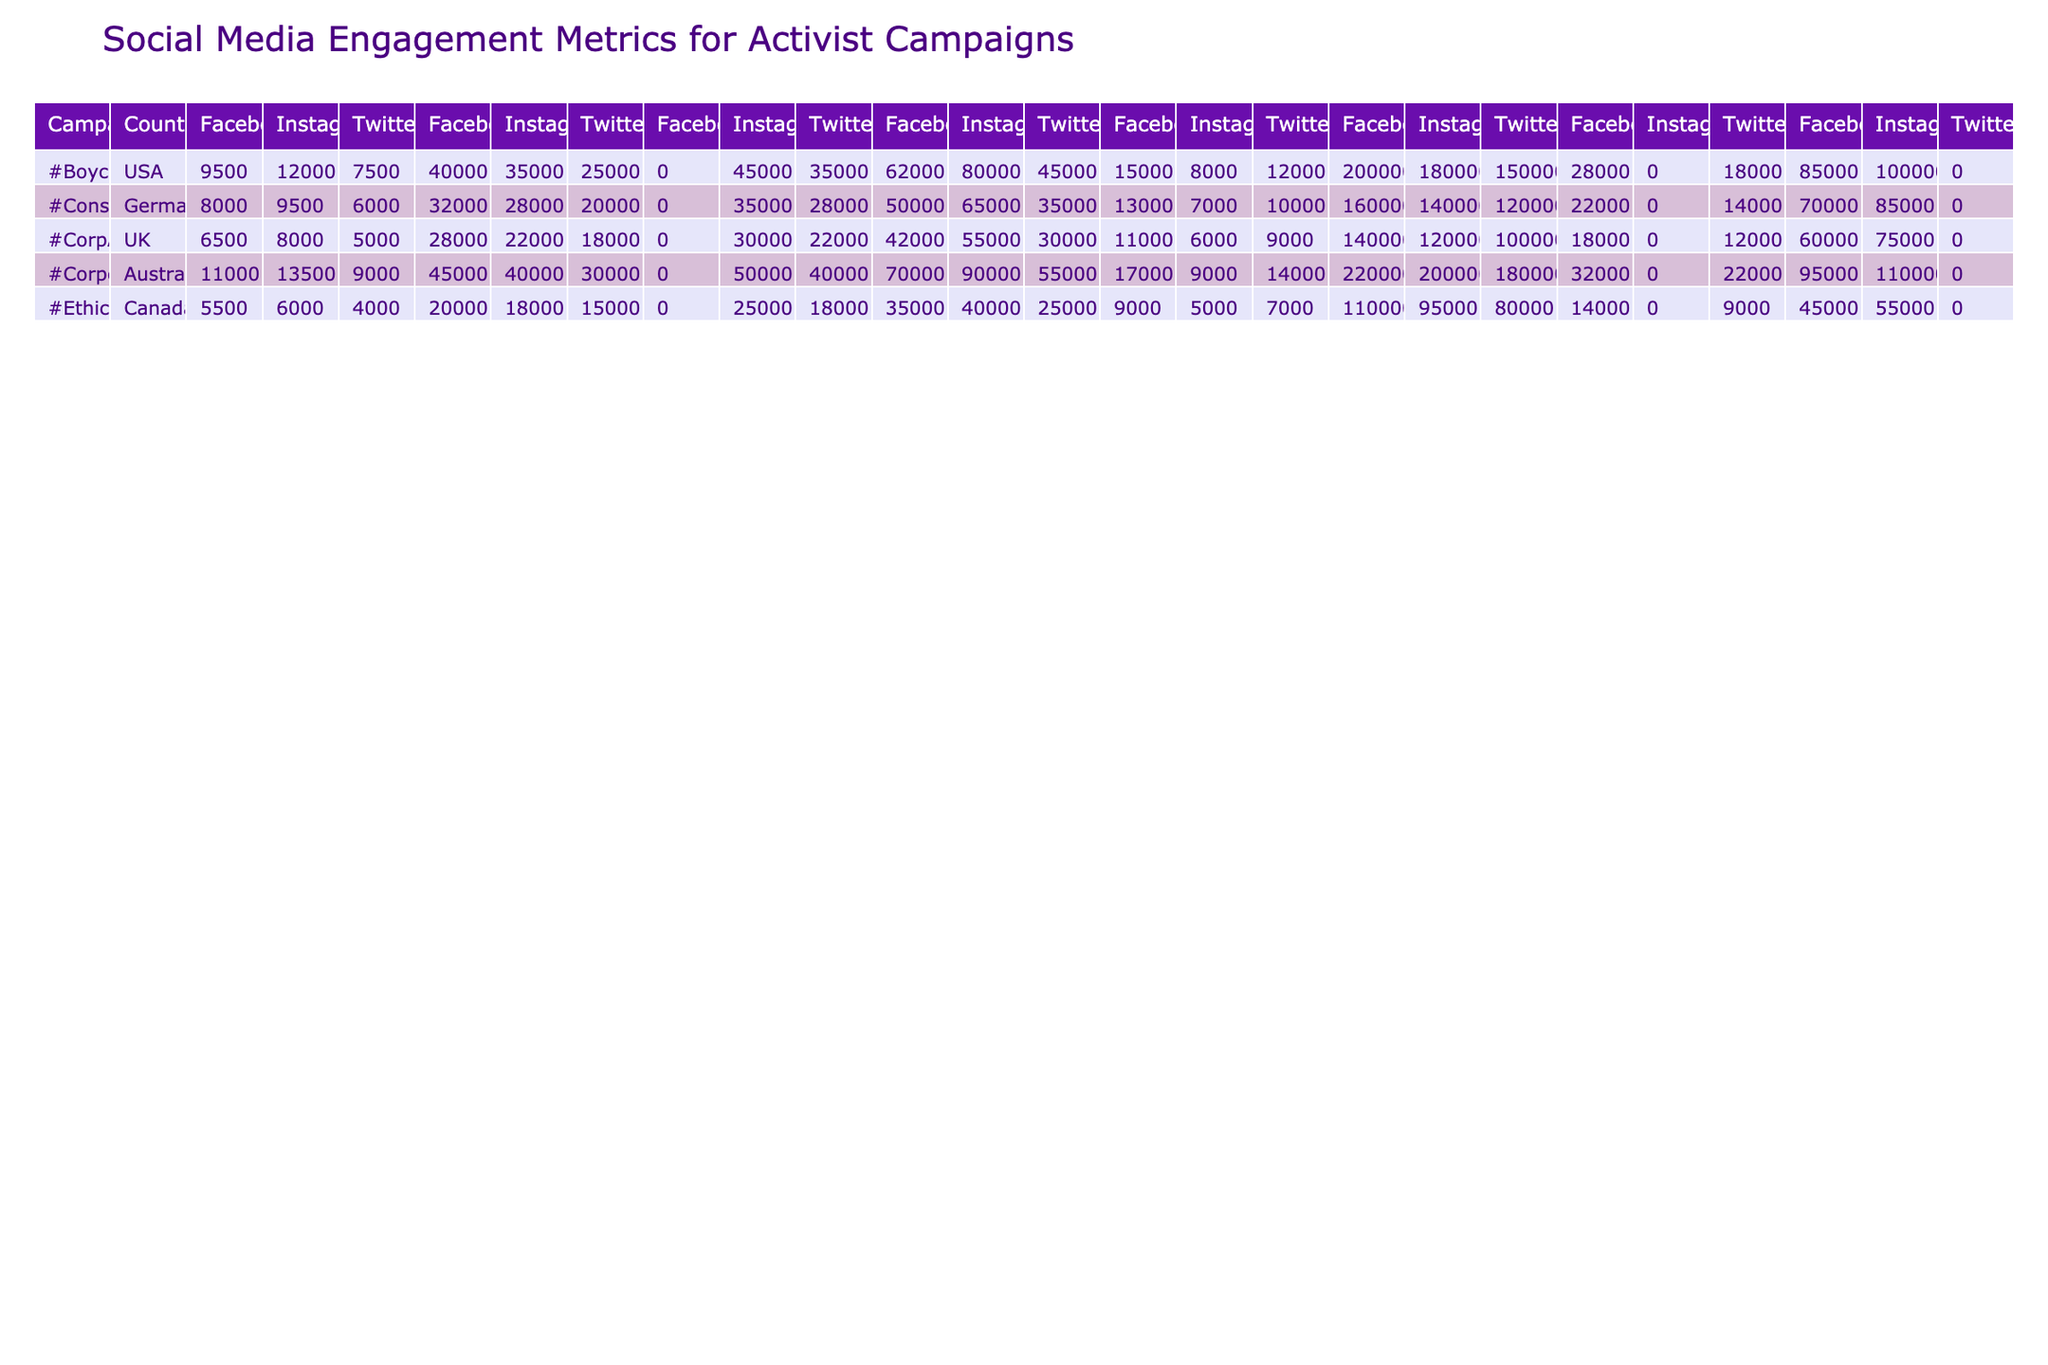What are the total video views for the #BoycottMegaCorp campaign on Facebook? The #BoycottMegaCorp campaign on Facebook has 0 video views according to the data in the table.
Answer: 0 What is the total number of shares on Instagram for the EthicalBusiness campaign? For the EthicalBusiness campaign on Instagram, the number of shares is 0 as per the table.
Answer: 0 Which campaign had the highest number of likes on Twitter? The CorporateGreed campaign had the highest number of likes on Twitter, with a total of 55,000.
Answer: CorporateGreed What is the combined reach of the CorpAccountability campaign across all platforms? The reach for CorpAccountability is 100,000 (Twitter) + 140,000 (Facebook) + 120,000 (Instagram) = 360,000 total reach.
Answer: 360000 For which platform does the #BoycottMegaCorp campaign have the highest number of followers? The #BoycottMegaCorp campaign has the highest number of followers on Facebook with 40,000, compared to Twitter and Instagram.
Answer: Facebook Does the ConsumerRights campaign have more comments on Instagram than on Twitter? The ConsumerRights campaign has 9,500 comments on Instagram and 6,000 on Twitter, so it is true that Instagram has more comments.
Answer: Yes What is the average number of likes for the EthicalBusiness campaign across all platforms? The total likes for EthicalBusiness are 25,000 (Twitter) + 35,000 (Facebook) + 40,000 (Instagram) = 100,000. Dividing this by the 3 platforms, the average is 100,000 / 3 = 33,333.
Answer: 33333 Which country has the campaign with the second highest reach on Facebook? The #CorpAccountability campaign in the UK has a reach of 140,000, while #CorporateGreed (Australia) has the highest at 220,000. Therefore, the UK has the second highest reach on Facebook.
Answer: UK What is the difference in hashtag uses between the CorporateGreed campaign and the EthicalBusiness campaign on Instagram? The hashtag uses for CorporateGreed on Instagram is 50,000 and for EthicalBusiness it is 25,000. The difference is 50,000 - 25,000 = 25,000.
Answer: 25000 